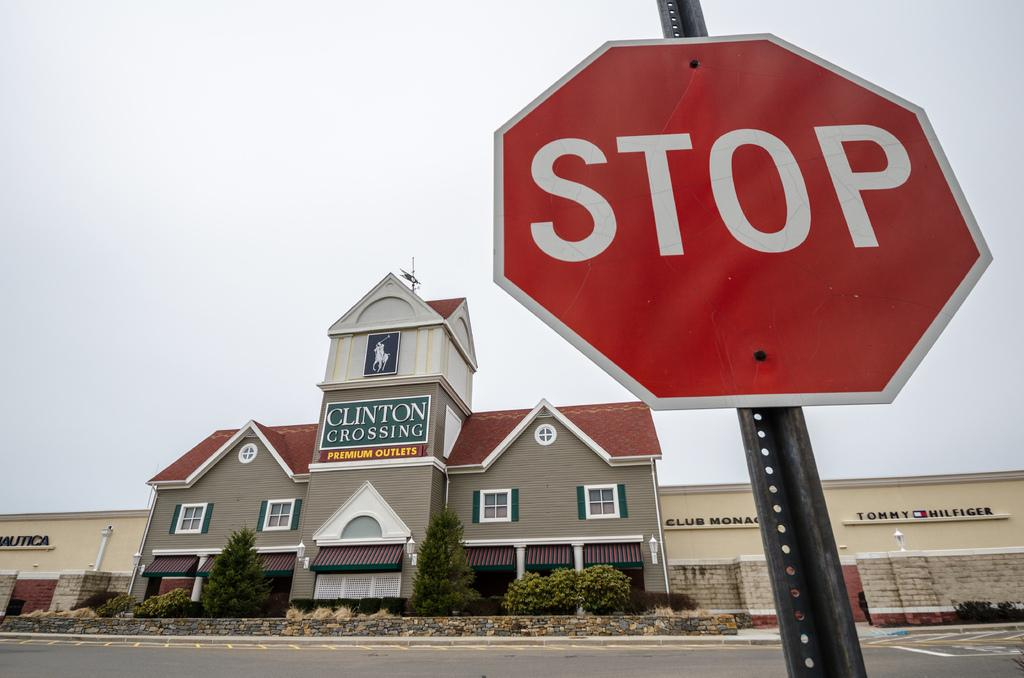<image>
Describe the image concisely. A red stop sign is in front of a building called Clinton Crossing. 